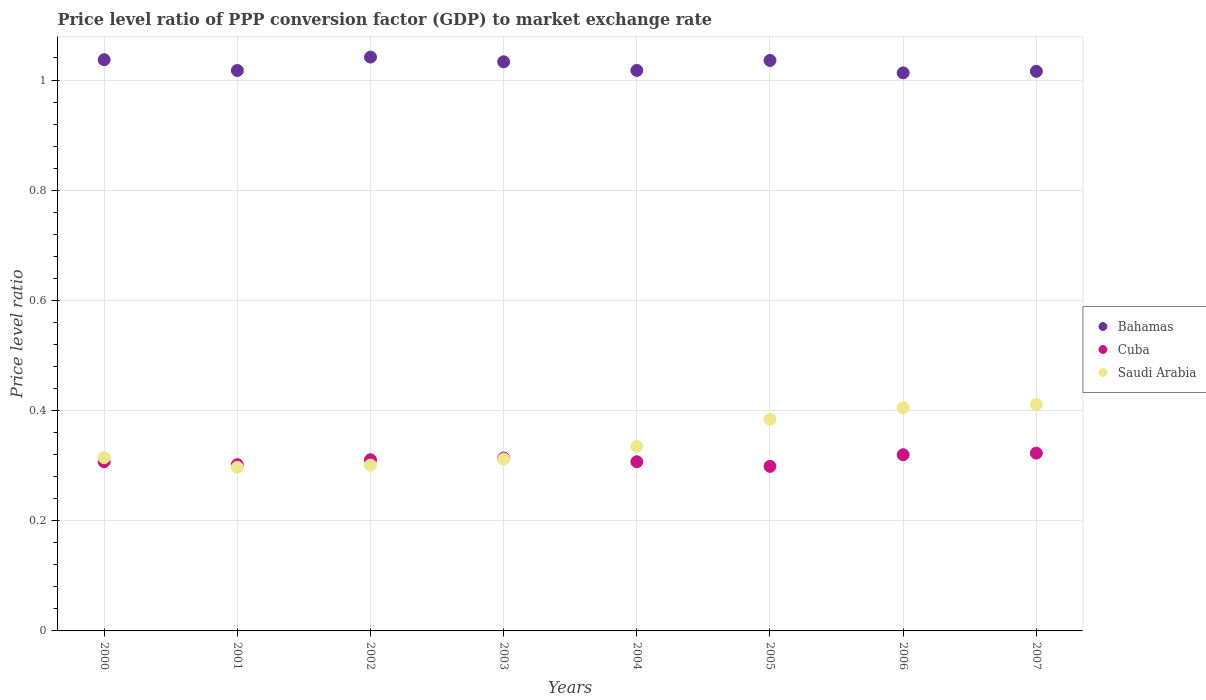Is the number of dotlines equal to the number of legend labels?
Provide a short and direct response. Yes. What is the price level ratio in Cuba in 2004?
Ensure brevity in your answer.  0.31. Across all years, what is the maximum price level ratio in Saudi Arabia?
Your answer should be compact. 0.41. Across all years, what is the minimum price level ratio in Cuba?
Provide a succinct answer. 0.3. In which year was the price level ratio in Cuba minimum?
Give a very brief answer. 2005. What is the total price level ratio in Cuba in the graph?
Keep it short and to the point. 2.48. What is the difference between the price level ratio in Saudi Arabia in 2001 and that in 2003?
Ensure brevity in your answer.  -0.01. What is the difference between the price level ratio in Saudi Arabia in 2006 and the price level ratio in Bahamas in 2000?
Provide a short and direct response. -0.63. What is the average price level ratio in Cuba per year?
Provide a short and direct response. 0.31. In the year 2000, what is the difference between the price level ratio in Bahamas and price level ratio in Cuba?
Your answer should be compact. 0.73. In how many years, is the price level ratio in Bahamas greater than 0.4?
Keep it short and to the point. 8. What is the ratio of the price level ratio in Bahamas in 2006 to that in 2007?
Offer a very short reply. 1. What is the difference between the highest and the second highest price level ratio in Saudi Arabia?
Give a very brief answer. 0.01. What is the difference between the highest and the lowest price level ratio in Cuba?
Make the answer very short. 0.02. Is the sum of the price level ratio in Saudi Arabia in 2004 and 2006 greater than the maximum price level ratio in Bahamas across all years?
Offer a very short reply. No. Is it the case that in every year, the sum of the price level ratio in Cuba and price level ratio in Bahamas  is greater than the price level ratio in Saudi Arabia?
Provide a short and direct response. Yes. Does the price level ratio in Cuba monotonically increase over the years?
Provide a short and direct response. No. Is the price level ratio in Bahamas strictly greater than the price level ratio in Cuba over the years?
Offer a very short reply. Yes. How many dotlines are there?
Provide a succinct answer. 3. How many years are there in the graph?
Ensure brevity in your answer.  8. Are the values on the major ticks of Y-axis written in scientific E-notation?
Offer a terse response. No. Does the graph contain any zero values?
Your answer should be very brief. No. Where does the legend appear in the graph?
Give a very brief answer. Center right. How many legend labels are there?
Give a very brief answer. 3. What is the title of the graph?
Make the answer very short. Price level ratio of PPP conversion factor (GDP) to market exchange rate. What is the label or title of the X-axis?
Ensure brevity in your answer.  Years. What is the label or title of the Y-axis?
Make the answer very short. Price level ratio. What is the Price level ratio in Bahamas in 2000?
Ensure brevity in your answer.  1.04. What is the Price level ratio in Cuba in 2000?
Your answer should be compact. 0.31. What is the Price level ratio of Saudi Arabia in 2000?
Give a very brief answer. 0.31. What is the Price level ratio in Bahamas in 2001?
Offer a very short reply. 1.02. What is the Price level ratio in Cuba in 2001?
Your response must be concise. 0.3. What is the Price level ratio in Saudi Arabia in 2001?
Your answer should be compact. 0.3. What is the Price level ratio in Bahamas in 2002?
Provide a short and direct response. 1.04. What is the Price level ratio in Cuba in 2002?
Ensure brevity in your answer.  0.31. What is the Price level ratio of Saudi Arabia in 2002?
Ensure brevity in your answer.  0.3. What is the Price level ratio in Bahamas in 2003?
Your response must be concise. 1.03. What is the Price level ratio of Cuba in 2003?
Offer a terse response. 0.31. What is the Price level ratio in Saudi Arabia in 2003?
Give a very brief answer. 0.31. What is the Price level ratio of Bahamas in 2004?
Give a very brief answer. 1.02. What is the Price level ratio in Cuba in 2004?
Your response must be concise. 0.31. What is the Price level ratio in Saudi Arabia in 2004?
Offer a terse response. 0.34. What is the Price level ratio of Bahamas in 2005?
Offer a very short reply. 1.04. What is the Price level ratio in Cuba in 2005?
Your answer should be compact. 0.3. What is the Price level ratio in Saudi Arabia in 2005?
Provide a short and direct response. 0.38. What is the Price level ratio of Bahamas in 2006?
Ensure brevity in your answer.  1.01. What is the Price level ratio of Cuba in 2006?
Give a very brief answer. 0.32. What is the Price level ratio of Saudi Arabia in 2006?
Your response must be concise. 0.41. What is the Price level ratio of Bahamas in 2007?
Your answer should be very brief. 1.02. What is the Price level ratio of Cuba in 2007?
Your response must be concise. 0.32. What is the Price level ratio in Saudi Arabia in 2007?
Your answer should be compact. 0.41. Across all years, what is the maximum Price level ratio of Bahamas?
Your response must be concise. 1.04. Across all years, what is the maximum Price level ratio of Cuba?
Offer a very short reply. 0.32. Across all years, what is the maximum Price level ratio in Saudi Arabia?
Ensure brevity in your answer.  0.41. Across all years, what is the minimum Price level ratio in Bahamas?
Offer a very short reply. 1.01. Across all years, what is the minimum Price level ratio in Cuba?
Make the answer very short. 0.3. Across all years, what is the minimum Price level ratio of Saudi Arabia?
Your response must be concise. 0.3. What is the total Price level ratio of Bahamas in the graph?
Your response must be concise. 8.21. What is the total Price level ratio in Cuba in the graph?
Your response must be concise. 2.48. What is the total Price level ratio of Saudi Arabia in the graph?
Make the answer very short. 2.76. What is the difference between the Price level ratio of Bahamas in 2000 and that in 2001?
Keep it short and to the point. 0.02. What is the difference between the Price level ratio in Cuba in 2000 and that in 2001?
Your answer should be compact. 0.01. What is the difference between the Price level ratio in Saudi Arabia in 2000 and that in 2001?
Your answer should be compact. 0.02. What is the difference between the Price level ratio of Bahamas in 2000 and that in 2002?
Offer a very short reply. -0. What is the difference between the Price level ratio in Cuba in 2000 and that in 2002?
Make the answer very short. -0. What is the difference between the Price level ratio in Saudi Arabia in 2000 and that in 2002?
Your answer should be compact. 0.01. What is the difference between the Price level ratio in Bahamas in 2000 and that in 2003?
Offer a terse response. 0. What is the difference between the Price level ratio of Cuba in 2000 and that in 2003?
Your response must be concise. -0.01. What is the difference between the Price level ratio of Saudi Arabia in 2000 and that in 2003?
Your answer should be very brief. 0. What is the difference between the Price level ratio in Bahamas in 2000 and that in 2004?
Provide a short and direct response. 0.02. What is the difference between the Price level ratio in Saudi Arabia in 2000 and that in 2004?
Your answer should be compact. -0.02. What is the difference between the Price level ratio of Bahamas in 2000 and that in 2005?
Keep it short and to the point. 0. What is the difference between the Price level ratio in Cuba in 2000 and that in 2005?
Make the answer very short. 0.01. What is the difference between the Price level ratio in Saudi Arabia in 2000 and that in 2005?
Offer a very short reply. -0.07. What is the difference between the Price level ratio in Bahamas in 2000 and that in 2006?
Make the answer very short. 0.02. What is the difference between the Price level ratio of Cuba in 2000 and that in 2006?
Offer a very short reply. -0.01. What is the difference between the Price level ratio of Saudi Arabia in 2000 and that in 2006?
Offer a terse response. -0.09. What is the difference between the Price level ratio of Bahamas in 2000 and that in 2007?
Your response must be concise. 0.02. What is the difference between the Price level ratio in Cuba in 2000 and that in 2007?
Your response must be concise. -0.02. What is the difference between the Price level ratio of Saudi Arabia in 2000 and that in 2007?
Offer a terse response. -0.1. What is the difference between the Price level ratio in Bahamas in 2001 and that in 2002?
Ensure brevity in your answer.  -0.02. What is the difference between the Price level ratio of Cuba in 2001 and that in 2002?
Provide a short and direct response. -0.01. What is the difference between the Price level ratio in Saudi Arabia in 2001 and that in 2002?
Ensure brevity in your answer.  -0. What is the difference between the Price level ratio of Bahamas in 2001 and that in 2003?
Give a very brief answer. -0.02. What is the difference between the Price level ratio of Cuba in 2001 and that in 2003?
Provide a short and direct response. -0.01. What is the difference between the Price level ratio in Saudi Arabia in 2001 and that in 2003?
Your answer should be very brief. -0.01. What is the difference between the Price level ratio of Bahamas in 2001 and that in 2004?
Your response must be concise. -0. What is the difference between the Price level ratio in Cuba in 2001 and that in 2004?
Keep it short and to the point. -0.01. What is the difference between the Price level ratio in Saudi Arabia in 2001 and that in 2004?
Your answer should be compact. -0.04. What is the difference between the Price level ratio of Bahamas in 2001 and that in 2005?
Ensure brevity in your answer.  -0.02. What is the difference between the Price level ratio in Cuba in 2001 and that in 2005?
Your response must be concise. 0. What is the difference between the Price level ratio of Saudi Arabia in 2001 and that in 2005?
Your answer should be compact. -0.09. What is the difference between the Price level ratio of Bahamas in 2001 and that in 2006?
Provide a short and direct response. 0. What is the difference between the Price level ratio of Cuba in 2001 and that in 2006?
Provide a succinct answer. -0.02. What is the difference between the Price level ratio of Saudi Arabia in 2001 and that in 2006?
Give a very brief answer. -0.11. What is the difference between the Price level ratio in Bahamas in 2001 and that in 2007?
Keep it short and to the point. 0. What is the difference between the Price level ratio in Cuba in 2001 and that in 2007?
Your response must be concise. -0.02. What is the difference between the Price level ratio of Saudi Arabia in 2001 and that in 2007?
Offer a terse response. -0.11. What is the difference between the Price level ratio of Bahamas in 2002 and that in 2003?
Give a very brief answer. 0.01. What is the difference between the Price level ratio of Cuba in 2002 and that in 2003?
Your answer should be very brief. -0. What is the difference between the Price level ratio of Saudi Arabia in 2002 and that in 2003?
Make the answer very short. -0.01. What is the difference between the Price level ratio of Bahamas in 2002 and that in 2004?
Your response must be concise. 0.02. What is the difference between the Price level ratio in Cuba in 2002 and that in 2004?
Provide a succinct answer. 0. What is the difference between the Price level ratio of Saudi Arabia in 2002 and that in 2004?
Ensure brevity in your answer.  -0.03. What is the difference between the Price level ratio of Bahamas in 2002 and that in 2005?
Provide a succinct answer. 0.01. What is the difference between the Price level ratio in Cuba in 2002 and that in 2005?
Keep it short and to the point. 0.01. What is the difference between the Price level ratio of Saudi Arabia in 2002 and that in 2005?
Provide a succinct answer. -0.08. What is the difference between the Price level ratio of Bahamas in 2002 and that in 2006?
Provide a succinct answer. 0.03. What is the difference between the Price level ratio of Cuba in 2002 and that in 2006?
Your answer should be compact. -0.01. What is the difference between the Price level ratio in Saudi Arabia in 2002 and that in 2006?
Your answer should be very brief. -0.1. What is the difference between the Price level ratio of Bahamas in 2002 and that in 2007?
Provide a short and direct response. 0.03. What is the difference between the Price level ratio of Cuba in 2002 and that in 2007?
Your answer should be very brief. -0.01. What is the difference between the Price level ratio in Saudi Arabia in 2002 and that in 2007?
Make the answer very short. -0.11. What is the difference between the Price level ratio in Bahamas in 2003 and that in 2004?
Your answer should be compact. 0.02. What is the difference between the Price level ratio in Cuba in 2003 and that in 2004?
Your response must be concise. 0.01. What is the difference between the Price level ratio of Saudi Arabia in 2003 and that in 2004?
Your answer should be compact. -0.02. What is the difference between the Price level ratio of Bahamas in 2003 and that in 2005?
Offer a very short reply. -0. What is the difference between the Price level ratio in Cuba in 2003 and that in 2005?
Provide a short and direct response. 0.01. What is the difference between the Price level ratio in Saudi Arabia in 2003 and that in 2005?
Keep it short and to the point. -0.07. What is the difference between the Price level ratio in Bahamas in 2003 and that in 2006?
Offer a terse response. 0.02. What is the difference between the Price level ratio in Cuba in 2003 and that in 2006?
Offer a very short reply. -0.01. What is the difference between the Price level ratio in Saudi Arabia in 2003 and that in 2006?
Your answer should be compact. -0.09. What is the difference between the Price level ratio in Bahamas in 2003 and that in 2007?
Offer a terse response. 0.02. What is the difference between the Price level ratio in Cuba in 2003 and that in 2007?
Your answer should be compact. -0.01. What is the difference between the Price level ratio of Saudi Arabia in 2003 and that in 2007?
Give a very brief answer. -0.1. What is the difference between the Price level ratio of Bahamas in 2004 and that in 2005?
Give a very brief answer. -0.02. What is the difference between the Price level ratio of Cuba in 2004 and that in 2005?
Your answer should be very brief. 0.01. What is the difference between the Price level ratio of Saudi Arabia in 2004 and that in 2005?
Give a very brief answer. -0.05. What is the difference between the Price level ratio of Bahamas in 2004 and that in 2006?
Keep it short and to the point. 0. What is the difference between the Price level ratio in Cuba in 2004 and that in 2006?
Keep it short and to the point. -0.01. What is the difference between the Price level ratio in Saudi Arabia in 2004 and that in 2006?
Offer a terse response. -0.07. What is the difference between the Price level ratio in Bahamas in 2004 and that in 2007?
Your response must be concise. 0. What is the difference between the Price level ratio in Cuba in 2004 and that in 2007?
Offer a very short reply. -0.02. What is the difference between the Price level ratio in Saudi Arabia in 2004 and that in 2007?
Provide a succinct answer. -0.08. What is the difference between the Price level ratio in Bahamas in 2005 and that in 2006?
Offer a terse response. 0.02. What is the difference between the Price level ratio in Cuba in 2005 and that in 2006?
Give a very brief answer. -0.02. What is the difference between the Price level ratio in Saudi Arabia in 2005 and that in 2006?
Give a very brief answer. -0.02. What is the difference between the Price level ratio in Bahamas in 2005 and that in 2007?
Give a very brief answer. 0.02. What is the difference between the Price level ratio of Cuba in 2005 and that in 2007?
Make the answer very short. -0.02. What is the difference between the Price level ratio of Saudi Arabia in 2005 and that in 2007?
Your answer should be very brief. -0.03. What is the difference between the Price level ratio of Bahamas in 2006 and that in 2007?
Your answer should be compact. -0. What is the difference between the Price level ratio in Cuba in 2006 and that in 2007?
Offer a terse response. -0. What is the difference between the Price level ratio in Saudi Arabia in 2006 and that in 2007?
Your response must be concise. -0.01. What is the difference between the Price level ratio of Bahamas in 2000 and the Price level ratio of Cuba in 2001?
Provide a short and direct response. 0.73. What is the difference between the Price level ratio in Bahamas in 2000 and the Price level ratio in Saudi Arabia in 2001?
Keep it short and to the point. 0.74. What is the difference between the Price level ratio in Cuba in 2000 and the Price level ratio in Saudi Arabia in 2001?
Offer a terse response. 0.01. What is the difference between the Price level ratio in Bahamas in 2000 and the Price level ratio in Cuba in 2002?
Keep it short and to the point. 0.73. What is the difference between the Price level ratio of Bahamas in 2000 and the Price level ratio of Saudi Arabia in 2002?
Your answer should be very brief. 0.74. What is the difference between the Price level ratio of Cuba in 2000 and the Price level ratio of Saudi Arabia in 2002?
Offer a very short reply. 0.01. What is the difference between the Price level ratio of Bahamas in 2000 and the Price level ratio of Cuba in 2003?
Make the answer very short. 0.72. What is the difference between the Price level ratio in Bahamas in 2000 and the Price level ratio in Saudi Arabia in 2003?
Provide a short and direct response. 0.72. What is the difference between the Price level ratio in Cuba in 2000 and the Price level ratio in Saudi Arabia in 2003?
Your answer should be very brief. -0. What is the difference between the Price level ratio of Bahamas in 2000 and the Price level ratio of Cuba in 2004?
Keep it short and to the point. 0.73. What is the difference between the Price level ratio in Bahamas in 2000 and the Price level ratio in Saudi Arabia in 2004?
Give a very brief answer. 0.7. What is the difference between the Price level ratio of Cuba in 2000 and the Price level ratio of Saudi Arabia in 2004?
Your answer should be compact. -0.03. What is the difference between the Price level ratio of Bahamas in 2000 and the Price level ratio of Cuba in 2005?
Keep it short and to the point. 0.74. What is the difference between the Price level ratio of Bahamas in 2000 and the Price level ratio of Saudi Arabia in 2005?
Offer a very short reply. 0.65. What is the difference between the Price level ratio in Cuba in 2000 and the Price level ratio in Saudi Arabia in 2005?
Ensure brevity in your answer.  -0.08. What is the difference between the Price level ratio in Bahamas in 2000 and the Price level ratio in Cuba in 2006?
Your answer should be very brief. 0.72. What is the difference between the Price level ratio in Bahamas in 2000 and the Price level ratio in Saudi Arabia in 2006?
Provide a short and direct response. 0.63. What is the difference between the Price level ratio of Cuba in 2000 and the Price level ratio of Saudi Arabia in 2006?
Your answer should be very brief. -0.1. What is the difference between the Price level ratio in Bahamas in 2000 and the Price level ratio in Cuba in 2007?
Offer a very short reply. 0.71. What is the difference between the Price level ratio of Bahamas in 2000 and the Price level ratio of Saudi Arabia in 2007?
Give a very brief answer. 0.63. What is the difference between the Price level ratio in Cuba in 2000 and the Price level ratio in Saudi Arabia in 2007?
Ensure brevity in your answer.  -0.1. What is the difference between the Price level ratio of Bahamas in 2001 and the Price level ratio of Cuba in 2002?
Your answer should be very brief. 0.71. What is the difference between the Price level ratio of Bahamas in 2001 and the Price level ratio of Saudi Arabia in 2002?
Provide a short and direct response. 0.72. What is the difference between the Price level ratio in Cuba in 2001 and the Price level ratio in Saudi Arabia in 2002?
Your answer should be very brief. 0. What is the difference between the Price level ratio in Bahamas in 2001 and the Price level ratio in Cuba in 2003?
Make the answer very short. 0.7. What is the difference between the Price level ratio of Bahamas in 2001 and the Price level ratio of Saudi Arabia in 2003?
Provide a short and direct response. 0.71. What is the difference between the Price level ratio in Cuba in 2001 and the Price level ratio in Saudi Arabia in 2003?
Provide a succinct answer. -0.01. What is the difference between the Price level ratio in Bahamas in 2001 and the Price level ratio in Cuba in 2004?
Ensure brevity in your answer.  0.71. What is the difference between the Price level ratio of Bahamas in 2001 and the Price level ratio of Saudi Arabia in 2004?
Offer a very short reply. 0.68. What is the difference between the Price level ratio in Cuba in 2001 and the Price level ratio in Saudi Arabia in 2004?
Give a very brief answer. -0.03. What is the difference between the Price level ratio in Bahamas in 2001 and the Price level ratio in Cuba in 2005?
Your answer should be very brief. 0.72. What is the difference between the Price level ratio of Bahamas in 2001 and the Price level ratio of Saudi Arabia in 2005?
Make the answer very short. 0.63. What is the difference between the Price level ratio of Cuba in 2001 and the Price level ratio of Saudi Arabia in 2005?
Your answer should be very brief. -0.08. What is the difference between the Price level ratio of Bahamas in 2001 and the Price level ratio of Cuba in 2006?
Offer a very short reply. 0.7. What is the difference between the Price level ratio in Bahamas in 2001 and the Price level ratio in Saudi Arabia in 2006?
Your answer should be very brief. 0.61. What is the difference between the Price level ratio in Cuba in 2001 and the Price level ratio in Saudi Arabia in 2006?
Your response must be concise. -0.1. What is the difference between the Price level ratio of Bahamas in 2001 and the Price level ratio of Cuba in 2007?
Give a very brief answer. 0.69. What is the difference between the Price level ratio of Bahamas in 2001 and the Price level ratio of Saudi Arabia in 2007?
Provide a short and direct response. 0.61. What is the difference between the Price level ratio of Cuba in 2001 and the Price level ratio of Saudi Arabia in 2007?
Provide a succinct answer. -0.11. What is the difference between the Price level ratio of Bahamas in 2002 and the Price level ratio of Cuba in 2003?
Provide a succinct answer. 0.73. What is the difference between the Price level ratio in Bahamas in 2002 and the Price level ratio in Saudi Arabia in 2003?
Your response must be concise. 0.73. What is the difference between the Price level ratio of Cuba in 2002 and the Price level ratio of Saudi Arabia in 2003?
Provide a short and direct response. -0. What is the difference between the Price level ratio in Bahamas in 2002 and the Price level ratio in Cuba in 2004?
Provide a short and direct response. 0.73. What is the difference between the Price level ratio in Bahamas in 2002 and the Price level ratio in Saudi Arabia in 2004?
Ensure brevity in your answer.  0.71. What is the difference between the Price level ratio of Cuba in 2002 and the Price level ratio of Saudi Arabia in 2004?
Keep it short and to the point. -0.02. What is the difference between the Price level ratio in Bahamas in 2002 and the Price level ratio in Cuba in 2005?
Keep it short and to the point. 0.74. What is the difference between the Price level ratio of Bahamas in 2002 and the Price level ratio of Saudi Arabia in 2005?
Make the answer very short. 0.66. What is the difference between the Price level ratio in Cuba in 2002 and the Price level ratio in Saudi Arabia in 2005?
Offer a terse response. -0.07. What is the difference between the Price level ratio in Bahamas in 2002 and the Price level ratio in Cuba in 2006?
Keep it short and to the point. 0.72. What is the difference between the Price level ratio of Bahamas in 2002 and the Price level ratio of Saudi Arabia in 2006?
Provide a short and direct response. 0.64. What is the difference between the Price level ratio in Cuba in 2002 and the Price level ratio in Saudi Arabia in 2006?
Your answer should be compact. -0.09. What is the difference between the Price level ratio of Bahamas in 2002 and the Price level ratio of Cuba in 2007?
Your response must be concise. 0.72. What is the difference between the Price level ratio in Bahamas in 2002 and the Price level ratio in Saudi Arabia in 2007?
Keep it short and to the point. 0.63. What is the difference between the Price level ratio of Cuba in 2002 and the Price level ratio of Saudi Arabia in 2007?
Your answer should be very brief. -0.1. What is the difference between the Price level ratio in Bahamas in 2003 and the Price level ratio in Cuba in 2004?
Your response must be concise. 0.73. What is the difference between the Price level ratio of Bahamas in 2003 and the Price level ratio of Saudi Arabia in 2004?
Your answer should be very brief. 0.7. What is the difference between the Price level ratio of Cuba in 2003 and the Price level ratio of Saudi Arabia in 2004?
Provide a short and direct response. -0.02. What is the difference between the Price level ratio of Bahamas in 2003 and the Price level ratio of Cuba in 2005?
Offer a terse response. 0.73. What is the difference between the Price level ratio in Bahamas in 2003 and the Price level ratio in Saudi Arabia in 2005?
Offer a very short reply. 0.65. What is the difference between the Price level ratio in Cuba in 2003 and the Price level ratio in Saudi Arabia in 2005?
Keep it short and to the point. -0.07. What is the difference between the Price level ratio of Bahamas in 2003 and the Price level ratio of Cuba in 2006?
Ensure brevity in your answer.  0.71. What is the difference between the Price level ratio of Bahamas in 2003 and the Price level ratio of Saudi Arabia in 2006?
Offer a terse response. 0.63. What is the difference between the Price level ratio in Cuba in 2003 and the Price level ratio in Saudi Arabia in 2006?
Give a very brief answer. -0.09. What is the difference between the Price level ratio of Bahamas in 2003 and the Price level ratio of Cuba in 2007?
Keep it short and to the point. 0.71. What is the difference between the Price level ratio of Bahamas in 2003 and the Price level ratio of Saudi Arabia in 2007?
Your response must be concise. 0.62. What is the difference between the Price level ratio in Cuba in 2003 and the Price level ratio in Saudi Arabia in 2007?
Your response must be concise. -0.1. What is the difference between the Price level ratio of Bahamas in 2004 and the Price level ratio of Cuba in 2005?
Ensure brevity in your answer.  0.72. What is the difference between the Price level ratio of Bahamas in 2004 and the Price level ratio of Saudi Arabia in 2005?
Provide a succinct answer. 0.63. What is the difference between the Price level ratio in Cuba in 2004 and the Price level ratio in Saudi Arabia in 2005?
Your answer should be compact. -0.08. What is the difference between the Price level ratio of Bahamas in 2004 and the Price level ratio of Cuba in 2006?
Your answer should be compact. 0.7. What is the difference between the Price level ratio of Bahamas in 2004 and the Price level ratio of Saudi Arabia in 2006?
Provide a short and direct response. 0.61. What is the difference between the Price level ratio of Cuba in 2004 and the Price level ratio of Saudi Arabia in 2006?
Keep it short and to the point. -0.1. What is the difference between the Price level ratio of Bahamas in 2004 and the Price level ratio of Cuba in 2007?
Your response must be concise. 0.69. What is the difference between the Price level ratio of Bahamas in 2004 and the Price level ratio of Saudi Arabia in 2007?
Keep it short and to the point. 0.61. What is the difference between the Price level ratio of Cuba in 2004 and the Price level ratio of Saudi Arabia in 2007?
Give a very brief answer. -0.1. What is the difference between the Price level ratio of Bahamas in 2005 and the Price level ratio of Cuba in 2006?
Keep it short and to the point. 0.72. What is the difference between the Price level ratio of Bahamas in 2005 and the Price level ratio of Saudi Arabia in 2006?
Offer a very short reply. 0.63. What is the difference between the Price level ratio in Cuba in 2005 and the Price level ratio in Saudi Arabia in 2006?
Provide a succinct answer. -0.11. What is the difference between the Price level ratio in Bahamas in 2005 and the Price level ratio in Cuba in 2007?
Your answer should be very brief. 0.71. What is the difference between the Price level ratio of Bahamas in 2005 and the Price level ratio of Saudi Arabia in 2007?
Offer a terse response. 0.62. What is the difference between the Price level ratio in Cuba in 2005 and the Price level ratio in Saudi Arabia in 2007?
Your answer should be compact. -0.11. What is the difference between the Price level ratio of Bahamas in 2006 and the Price level ratio of Cuba in 2007?
Provide a short and direct response. 0.69. What is the difference between the Price level ratio in Bahamas in 2006 and the Price level ratio in Saudi Arabia in 2007?
Ensure brevity in your answer.  0.6. What is the difference between the Price level ratio of Cuba in 2006 and the Price level ratio of Saudi Arabia in 2007?
Provide a succinct answer. -0.09. What is the average Price level ratio of Bahamas per year?
Your answer should be compact. 1.03. What is the average Price level ratio in Cuba per year?
Ensure brevity in your answer.  0.31. What is the average Price level ratio of Saudi Arabia per year?
Ensure brevity in your answer.  0.34. In the year 2000, what is the difference between the Price level ratio in Bahamas and Price level ratio in Cuba?
Offer a terse response. 0.73. In the year 2000, what is the difference between the Price level ratio in Bahamas and Price level ratio in Saudi Arabia?
Your answer should be very brief. 0.72. In the year 2000, what is the difference between the Price level ratio in Cuba and Price level ratio in Saudi Arabia?
Ensure brevity in your answer.  -0.01. In the year 2001, what is the difference between the Price level ratio in Bahamas and Price level ratio in Cuba?
Keep it short and to the point. 0.72. In the year 2001, what is the difference between the Price level ratio in Bahamas and Price level ratio in Saudi Arabia?
Offer a very short reply. 0.72. In the year 2001, what is the difference between the Price level ratio of Cuba and Price level ratio of Saudi Arabia?
Offer a terse response. 0. In the year 2002, what is the difference between the Price level ratio in Bahamas and Price level ratio in Cuba?
Give a very brief answer. 0.73. In the year 2002, what is the difference between the Price level ratio in Bahamas and Price level ratio in Saudi Arabia?
Ensure brevity in your answer.  0.74. In the year 2002, what is the difference between the Price level ratio in Cuba and Price level ratio in Saudi Arabia?
Keep it short and to the point. 0.01. In the year 2003, what is the difference between the Price level ratio in Bahamas and Price level ratio in Cuba?
Make the answer very short. 0.72. In the year 2003, what is the difference between the Price level ratio in Bahamas and Price level ratio in Saudi Arabia?
Make the answer very short. 0.72. In the year 2003, what is the difference between the Price level ratio of Cuba and Price level ratio of Saudi Arabia?
Give a very brief answer. 0. In the year 2004, what is the difference between the Price level ratio in Bahamas and Price level ratio in Cuba?
Offer a terse response. 0.71. In the year 2004, what is the difference between the Price level ratio in Bahamas and Price level ratio in Saudi Arabia?
Your answer should be very brief. 0.68. In the year 2004, what is the difference between the Price level ratio of Cuba and Price level ratio of Saudi Arabia?
Provide a short and direct response. -0.03. In the year 2005, what is the difference between the Price level ratio in Bahamas and Price level ratio in Cuba?
Give a very brief answer. 0.74. In the year 2005, what is the difference between the Price level ratio in Bahamas and Price level ratio in Saudi Arabia?
Your answer should be very brief. 0.65. In the year 2005, what is the difference between the Price level ratio in Cuba and Price level ratio in Saudi Arabia?
Give a very brief answer. -0.09. In the year 2006, what is the difference between the Price level ratio in Bahamas and Price level ratio in Cuba?
Your answer should be very brief. 0.69. In the year 2006, what is the difference between the Price level ratio in Bahamas and Price level ratio in Saudi Arabia?
Your response must be concise. 0.61. In the year 2006, what is the difference between the Price level ratio in Cuba and Price level ratio in Saudi Arabia?
Your response must be concise. -0.09. In the year 2007, what is the difference between the Price level ratio of Bahamas and Price level ratio of Cuba?
Your response must be concise. 0.69. In the year 2007, what is the difference between the Price level ratio in Bahamas and Price level ratio in Saudi Arabia?
Your response must be concise. 0.6. In the year 2007, what is the difference between the Price level ratio of Cuba and Price level ratio of Saudi Arabia?
Make the answer very short. -0.09. What is the ratio of the Price level ratio in Bahamas in 2000 to that in 2001?
Give a very brief answer. 1.02. What is the ratio of the Price level ratio of Cuba in 2000 to that in 2001?
Offer a terse response. 1.02. What is the ratio of the Price level ratio of Saudi Arabia in 2000 to that in 2001?
Your response must be concise. 1.06. What is the ratio of the Price level ratio of Bahamas in 2000 to that in 2002?
Your response must be concise. 1. What is the ratio of the Price level ratio in Cuba in 2000 to that in 2002?
Your answer should be compact. 0.99. What is the ratio of the Price level ratio of Saudi Arabia in 2000 to that in 2002?
Your answer should be very brief. 1.04. What is the ratio of the Price level ratio in Cuba in 2000 to that in 2003?
Make the answer very short. 0.98. What is the ratio of the Price level ratio in Saudi Arabia in 2000 to that in 2003?
Offer a terse response. 1.01. What is the ratio of the Price level ratio of Bahamas in 2000 to that in 2004?
Offer a very short reply. 1.02. What is the ratio of the Price level ratio of Cuba in 2000 to that in 2004?
Your answer should be compact. 1. What is the ratio of the Price level ratio of Saudi Arabia in 2000 to that in 2004?
Keep it short and to the point. 0.94. What is the ratio of the Price level ratio of Bahamas in 2000 to that in 2005?
Your response must be concise. 1. What is the ratio of the Price level ratio in Cuba in 2000 to that in 2005?
Give a very brief answer. 1.03. What is the ratio of the Price level ratio of Saudi Arabia in 2000 to that in 2005?
Your response must be concise. 0.82. What is the ratio of the Price level ratio of Bahamas in 2000 to that in 2006?
Provide a succinct answer. 1.02. What is the ratio of the Price level ratio in Cuba in 2000 to that in 2006?
Your answer should be very brief. 0.96. What is the ratio of the Price level ratio of Saudi Arabia in 2000 to that in 2006?
Keep it short and to the point. 0.78. What is the ratio of the Price level ratio in Bahamas in 2000 to that in 2007?
Offer a terse response. 1.02. What is the ratio of the Price level ratio of Cuba in 2000 to that in 2007?
Your response must be concise. 0.95. What is the ratio of the Price level ratio of Saudi Arabia in 2000 to that in 2007?
Provide a short and direct response. 0.77. What is the ratio of the Price level ratio in Bahamas in 2001 to that in 2002?
Offer a terse response. 0.98. What is the ratio of the Price level ratio in Cuba in 2001 to that in 2002?
Offer a very short reply. 0.97. What is the ratio of the Price level ratio in Saudi Arabia in 2001 to that in 2002?
Keep it short and to the point. 0.99. What is the ratio of the Price level ratio of Cuba in 2001 to that in 2003?
Ensure brevity in your answer.  0.96. What is the ratio of the Price level ratio of Saudi Arabia in 2001 to that in 2003?
Keep it short and to the point. 0.95. What is the ratio of the Price level ratio of Cuba in 2001 to that in 2004?
Give a very brief answer. 0.98. What is the ratio of the Price level ratio of Saudi Arabia in 2001 to that in 2004?
Make the answer very short. 0.89. What is the ratio of the Price level ratio of Bahamas in 2001 to that in 2005?
Give a very brief answer. 0.98. What is the ratio of the Price level ratio in Cuba in 2001 to that in 2005?
Provide a short and direct response. 1.01. What is the ratio of the Price level ratio of Saudi Arabia in 2001 to that in 2005?
Ensure brevity in your answer.  0.77. What is the ratio of the Price level ratio of Cuba in 2001 to that in 2006?
Offer a terse response. 0.94. What is the ratio of the Price level ratio of Saudi Arabia in 2001 to that in 2006?
Provide a short and direct response. 0.73. What is the ratio of the Price level ratio in Cuba in 2001 to that in 2007?
Provide a succinct answer. 0.94. What is the ratio of the Price level ratio of Saudi Arabia in 2001 to that in 2007?
Your answer should be very brief. 0.72. What is the ratio of the Price level ratio in Bahamas in 2002 to that in 2003?
Ensure brevity in your answer.  1.01. What is the ratio of the Price level ratio in Saudi Arabia in 2002 to that in 2003?
Keep it short and to the point. 0.96. What is the ratio of the Price level ratio of Bahamas in 2002 to that in 2004?
Your response must be concise. 1.02. What is the ratio of the Price level ratio in Cuba in 2002 to that in 2004?
Your answer should be compact. 1.01. What is the ratio of the Price level ratio of Saudi Arabia in 2002 to that in 2004?
Make the answer very short. 0.9. What is the ratio of the Price level ratio in Bahamas in 2002 to that in 2005?
Offer a terse response. 1.01. What is the ratio of the Price level ratio in Cuba in 2002 to that in 2005?
Keep it short and to the point. 1.04. What is the ratio of the Price level ratio in Saudi Arabia in 2002 to that in 2005?
Give a very brief answer. 0.78. What is the ratio of the Price level ratio in Bahamas in 2002 to that in 2006?
Offer a very short reply. 1.03. What is the ratio of the Price level ratio of Cuba in 2002 to that in 2006?
Offer a very short reply. 0.97. What is the ratio of the Price level ratio in Saudi Arabia in 2002 to that in 2006?
Your response must be concise. 0.74. What is the ratio of the Price level ratio in Bahamas in 2002 to that in 2007?
Your answer should be very brief. 1.03. What is the ratio of the Price level ratio in Cuba in 2002 to that in 2007?
Keep it short and to the point. 0.96. What is the ratio of the Price level ratio in Saudi Arabia in 2002 to that in 2007?
Offer a terse response. 0.73. What is the ratio of the Price level ratio of Bahamas in 2003 to that in 2004?
Offer a terse response. 1.02. What is the ratio of the Price level ratio of Cuba in 2003 to that in 2004?
Offer a terse response. 1.02. What is the ratio of the Price level ratio of Saudi Arabia in 2003 to that in 2004?
Offer a very short reply. 0.93. What is the ratio of the Price level ratio in Cuba in 2003 to that in 2005?
Ensure brevity in your answer.  1.05. What is the ratio of the Price level ratio in Saudi Arabia in 2003 to that in 2005?
Give a very brief answer. 0.81. What is the ratio of the Price level ratio in Bahamas in 2003 to that in 2006?
Keep it short and to the point. 1.02. What is the ratio of the Price level ratio in Cuba in 2003 to that in 2006?
Your answer should be very brief. 0.98. What is the ratio of the Price level ratio of Saudi Arabia in 2003 to that in 2006?
Your response must be concise. 0.77. What is the ratio of the Price level ratio in Cuba in 2003 to that in 2007?
Make the answer very short. 0.97. What is the ratio of the Price level ratio of Saudi Arabia in 2003 to that in 2007?
Give a very brief answer. 0.76. What is the ratio of the Price level ratio of Bahamas in 2004 to that in 2005?
Offer a very short reply. 0.98. What is the ratio of the Price level ratio in Cuba in 2004 to that in 2005?
Your answer should be compact. 1.03. What is the ratio of the Price level ratio of Saudi Arabia in 2004 to that in 2005?
Offer a terse response. 0.87. What is the ratio of the Price level ratio in Cuba in 2004 to that in 2006?
Your answer should be compact. 0.96. What is the ratio of the Price level ratio of Saudi Arabia in 2004 to that in 2006?
Offer a terse response. 0.83. What is the ratio of the Price level ratio of Bahamas in 2004 to that in 2007?
Your response must be concise. 1. What is the ratio of the Price level ratio in Cuba in 2004 to that in 2007?
Ensure brevity in your answer.  0.95. What is the ratio of the Price level ratio of Saudi Arabia in 2004 to that in 2007?
Your response must be concise. 0.82. What is the ratio of the Price level ratio of Bahamas in 2005 to that in 2006?
Make the answer very short. 1.02. What is the ratio of the Price level ratio in Cuba in 2005 to that in 2006?
Provide a short and direct response. 0.93. What is the ratio of the Price level ratio in Saudi Arabia in 2005 to that in 2006?
Provide a short and direct response. 0.95. What is the ratio of the Price level ratio of Bahamas in 2005 to that in 2007?
Give a very brief answer. 1.02. What is the ratio of the Price level ratio in Cuba in 2005 to that in 2007?
Your answer should be compact. 0.93. What is the ratio of the Price level ratio in Saudi Arabia in 2005 to that in 2007?
Your response must be concise. 0.94. What is the ratio of the Price level ratio in Bahamas in 2006 to that in 2007?
Give a very brief answer. 1. What is the ratio of the Price level ratio in Cuba in 2006 to that in 2007?
Your answer should be very brief. 0.99. What is the ratio of the Price level ratio of Saudi Arabia in 2006 to that in 2007?
Give a very brief answer. 0.99. What is the difference between the highest and the second highest Price level ratio in Bahamas?
Offer a very short reply. 0. What is the difference between the highest and the second highest Price level ratio in Cuba?
Make the answer very short. 0. What is the difference between the highest and the second highest Price level ratio of Saudi Arabia?
Your answer should be very brief. 0.01. What is the difference between the highest and the lowest Price level ratio of Bahamas?
Keep it short and to the point. 0.03. What is the difference between the highest and the lowest Price level ratio of Cuba?
Ensure brevity in your answer.  0.02. What is the difference between the highest and the lowest Price level ratio of Saudi Arabia?
Your answer should be very brief. 0.11. 